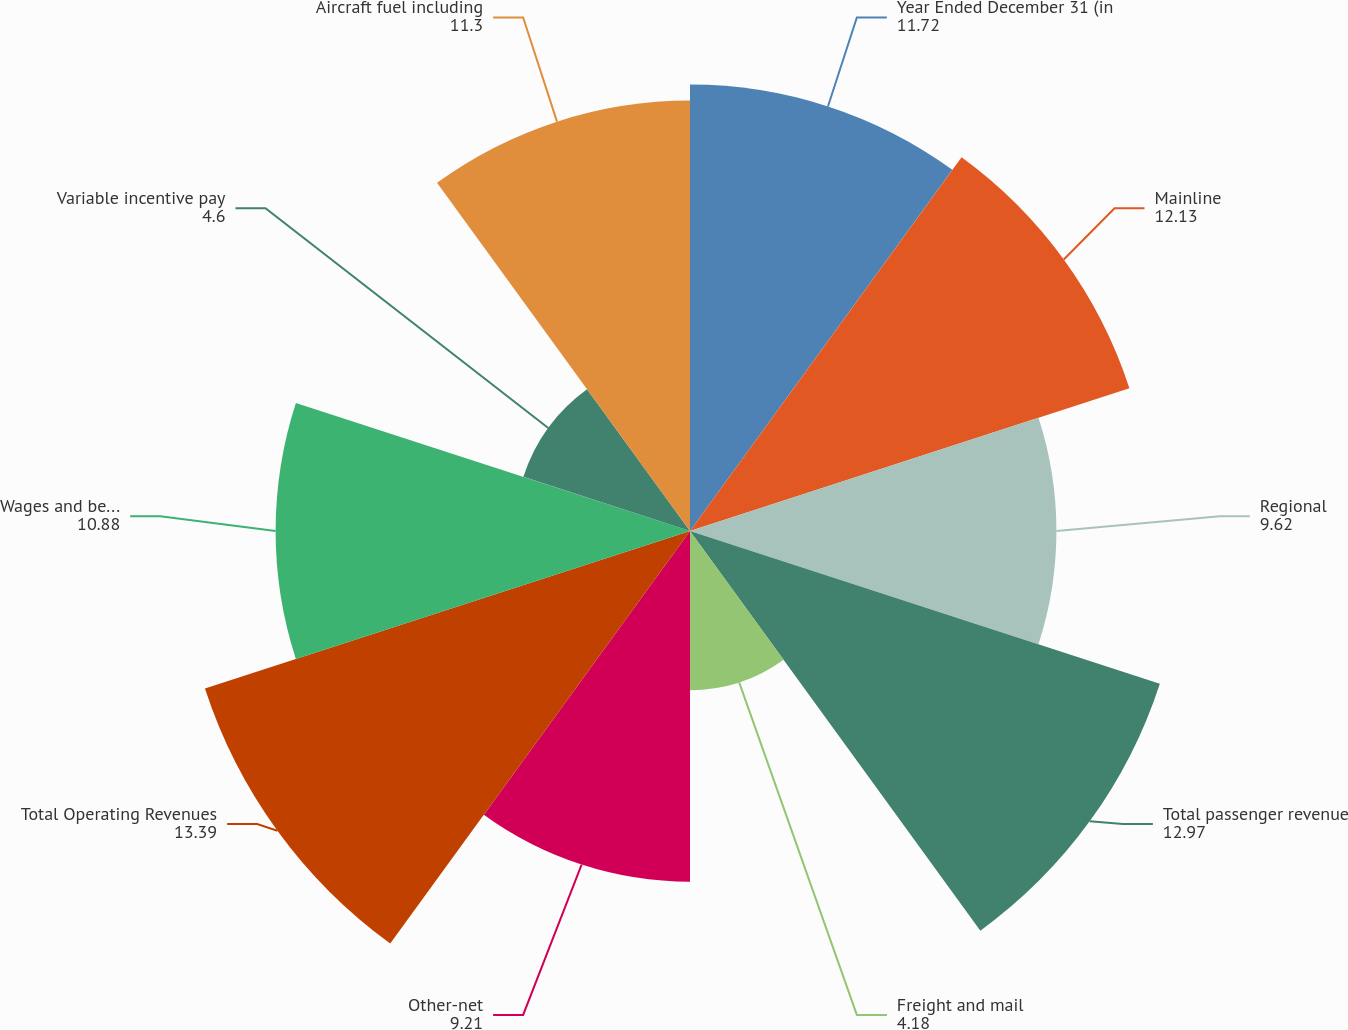<chart> <loc_0><loc_0><loc_500><loc_500><pie_chart><fcel>Year Ended December 31 (in<fcel>Mainline<fcel>Regional<fcel>Total passenger revenue<fcel>Freight and mail<fcel>Other-net<fcel>Total Operating Revenues<fcel>Wages and benefits<fcel>Variable incentive pay<fcel>Aircraft fuel including<nl><fcel>11.72%<fcel>12.13%<fcel>9.62%<fcel>12.97%<fcel>4.18%<fcel>9.21%<fcel>13.39%<fcel>10.88%<fcel>4.6%<fcel>11.3%<nl></chart> 